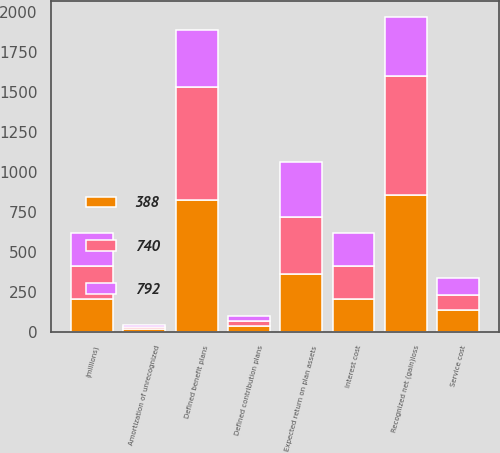<chart> <loc_0><loc_0><loc_500><loc_500><stacked_bar_chart><ecel><fcel>(millions)<fcel>Service cost<fcel>Interest cost<fcel>Expected return on plan assets<fcel>Amortization of unrecognized<fcel>Recognized net (gain)loss<fcel>Defined benefit plans<fcel>Defined contribution plans<nl><fcel>388<fcel>207<fcel>133<fcel>203<fcel>359<fcel>16<fcel>854<fcel>827<fcel>35<nl><fcel>792<fcel>207<fcel>110<fcel>207<fcel>344<fcel>14<fcel>372<fcel>359<fcel>29<nl><fcel>740<fcel>207<fcel>96<fcel>209<fcel>361<fcel>14<fcel>747<fcel>705<fcel>35<nl></chart> 